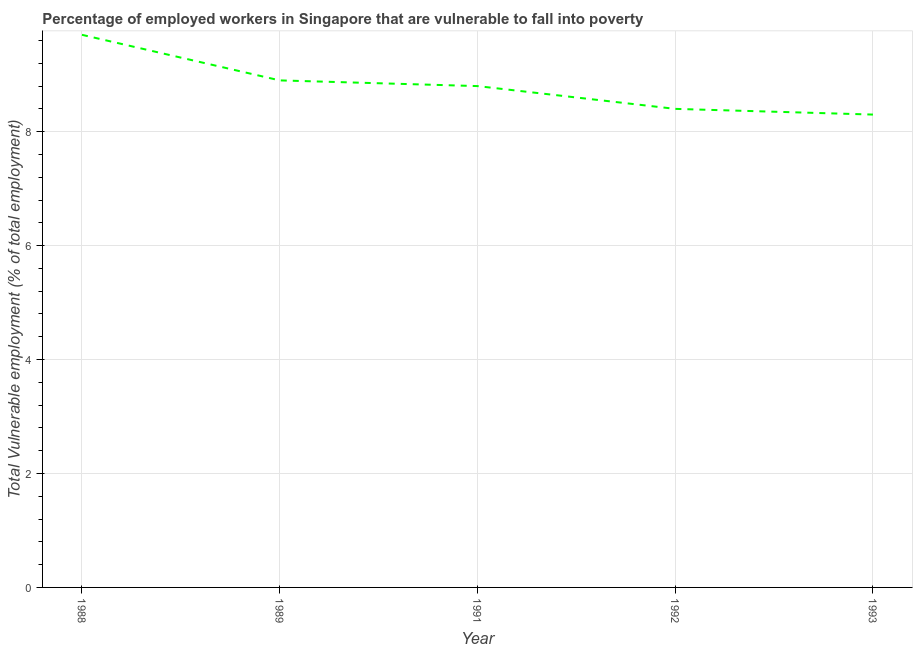What is the total vulnerable employment in 1989?
Keep it short and to the point. 8.9. Across all years, what is the maximum total vulnerable employment?
Your response must be concise. 9.7. Across all years, what is the minimum total vulnerable employment?
Your answer should be very brief. 8.3. In which year was the total vulnerable employment minimum?
Make the answer very short. 1993. What is the sum of the total vulnerable employment?
Provide a succinct answer. 44.1. What is the difference between the total vulnerable employment in 1991 and 1992?
Provide a succinct answer. 0.4. What is the average total vulnerable employment per year?
Provide a short and direct response. 8.82. What is the median total vulnerable employment?
Give a very brief answer. 8.8. Do a majority of the years between 1989 and 1988 (inclusive) have total vulnerable employment greater than 0.4 %?
Offer a terse response. No. What is the ratio of the total vulnerable employment in 1991 to that in 1993?
Provide a short and direct response. 1.06. Is the total vulnerable employment in 1989 less than that in 1991?
Offer a very short reply. No. What is the difference between the highest and the second highest total vulnerable employment?
Offer a terse response. 0.8. What is the difference between the highest and the lowest total vulnerable employment?
Offer a very short reply. 1.4. Does the total vulnerable employment monotonically increase over the years?
Your answer should be very brief. No. How many years are there in the graph?
Your answer should be compact. 5. What is the title of the graph?
Ensure brevity in your answer.  Percentage of employed workers in Singapore that are vulnerable to fall into poverty. What is the label or title of the X-axis?
Make the answer very short. Year. What is the label or title of the Y-axis?
Provide a short and direct response. Total Vulnerable employment (% of total employment). What is the Total Vulnerable employment (% of total employment) in 1988?
Make the answer very short. 9.7. What is the Total Vulnerable employment (% of total employment) of 1989?
Offer a terse response. 8.9. What is the Total Vulnerable employment (% of total employment) of 1991?
Your response must be concise. 8.8. What is the Total Vulnerable employment (% of total employment) of 1992?
Offer a very short reply. 8.4. What is the Total Vulnerable employment (% of total employment) of 1993?
Ensure brevity in your answer.  8.3. What is the difference between the Total Vulnerable employment (% of total employment) in 1988 and 1991?
Make the answer very short. 0.9. What is the difference between the Total Vulnerable employment (% of total employment) in 1988 and 1992?
Your answer should be compact. 1.3. What is the difference between the Total Vulnerable employment (% of total employment) in 1988 and 1993?
Offer a terse response. 1.4. What is the difference between the Total Vulnerable employment (% of total employment) in 1989 and 1991?
Keep it short and to the point. 0.1. What is the difference between the Total Vulnerable employment (% of total employment) in 1989 and 1993?
Offer a very short reply. 0.6. What is the difference between the Total Vulnerable employment (% of total employment) in 1991 and 1992?
Make the answer very short. 0.4. What is the difference between the Total Vulnerable employment (% of total employment) in 1991 and 1993?
Your response must be concise. 0.5. What is the difference between the Total Vulnerable employment (% of total employment) in 1992 and 1993?
Make the answer very short. 0.1. What is the ratio of the Total Vulnerable employment (% of total employment) in 1988 to that in 1989?
Make the answer very short. 1.09. What is the ratio of the Total Vulnerable employment (% of total employment) in 1988 to that in 1991?
Your answer should be compact. 1.1. What is the ratio of the Total Vulnerable employment (% of total employment) in 1988 to that in 1992?
Ensure brevity in your answer.  1.16. What is the ratio of the Total Vulnerable employment (% of total employment) in 1988 to that in 1993?
Your response must be concise. 1.17. What is the ratio of the Total Vulnerable employment (% of total employment) in 1989 to that in 1991?
Keep it short and to the point. 1.01. What is the ratio of the Total Vulnerable employment (% of total employment) in 1989 to that in 1992?
Give a very brief answer. 1.06. What is the ratio of the Total Vulnerable employment (% of total employment) in 1989 to that in 1993?
Provide a succinct answer. 1.07. What is the ratio of the Total Vulnerable employment (% of total employment) in 1991 to that in 1992?
Your response must be concise. 1.05. What is the ratio of the Total Vulnerable employment (% of total employment) in 1991 to that in 1993?
Keep it short and to the point. 1.06. 